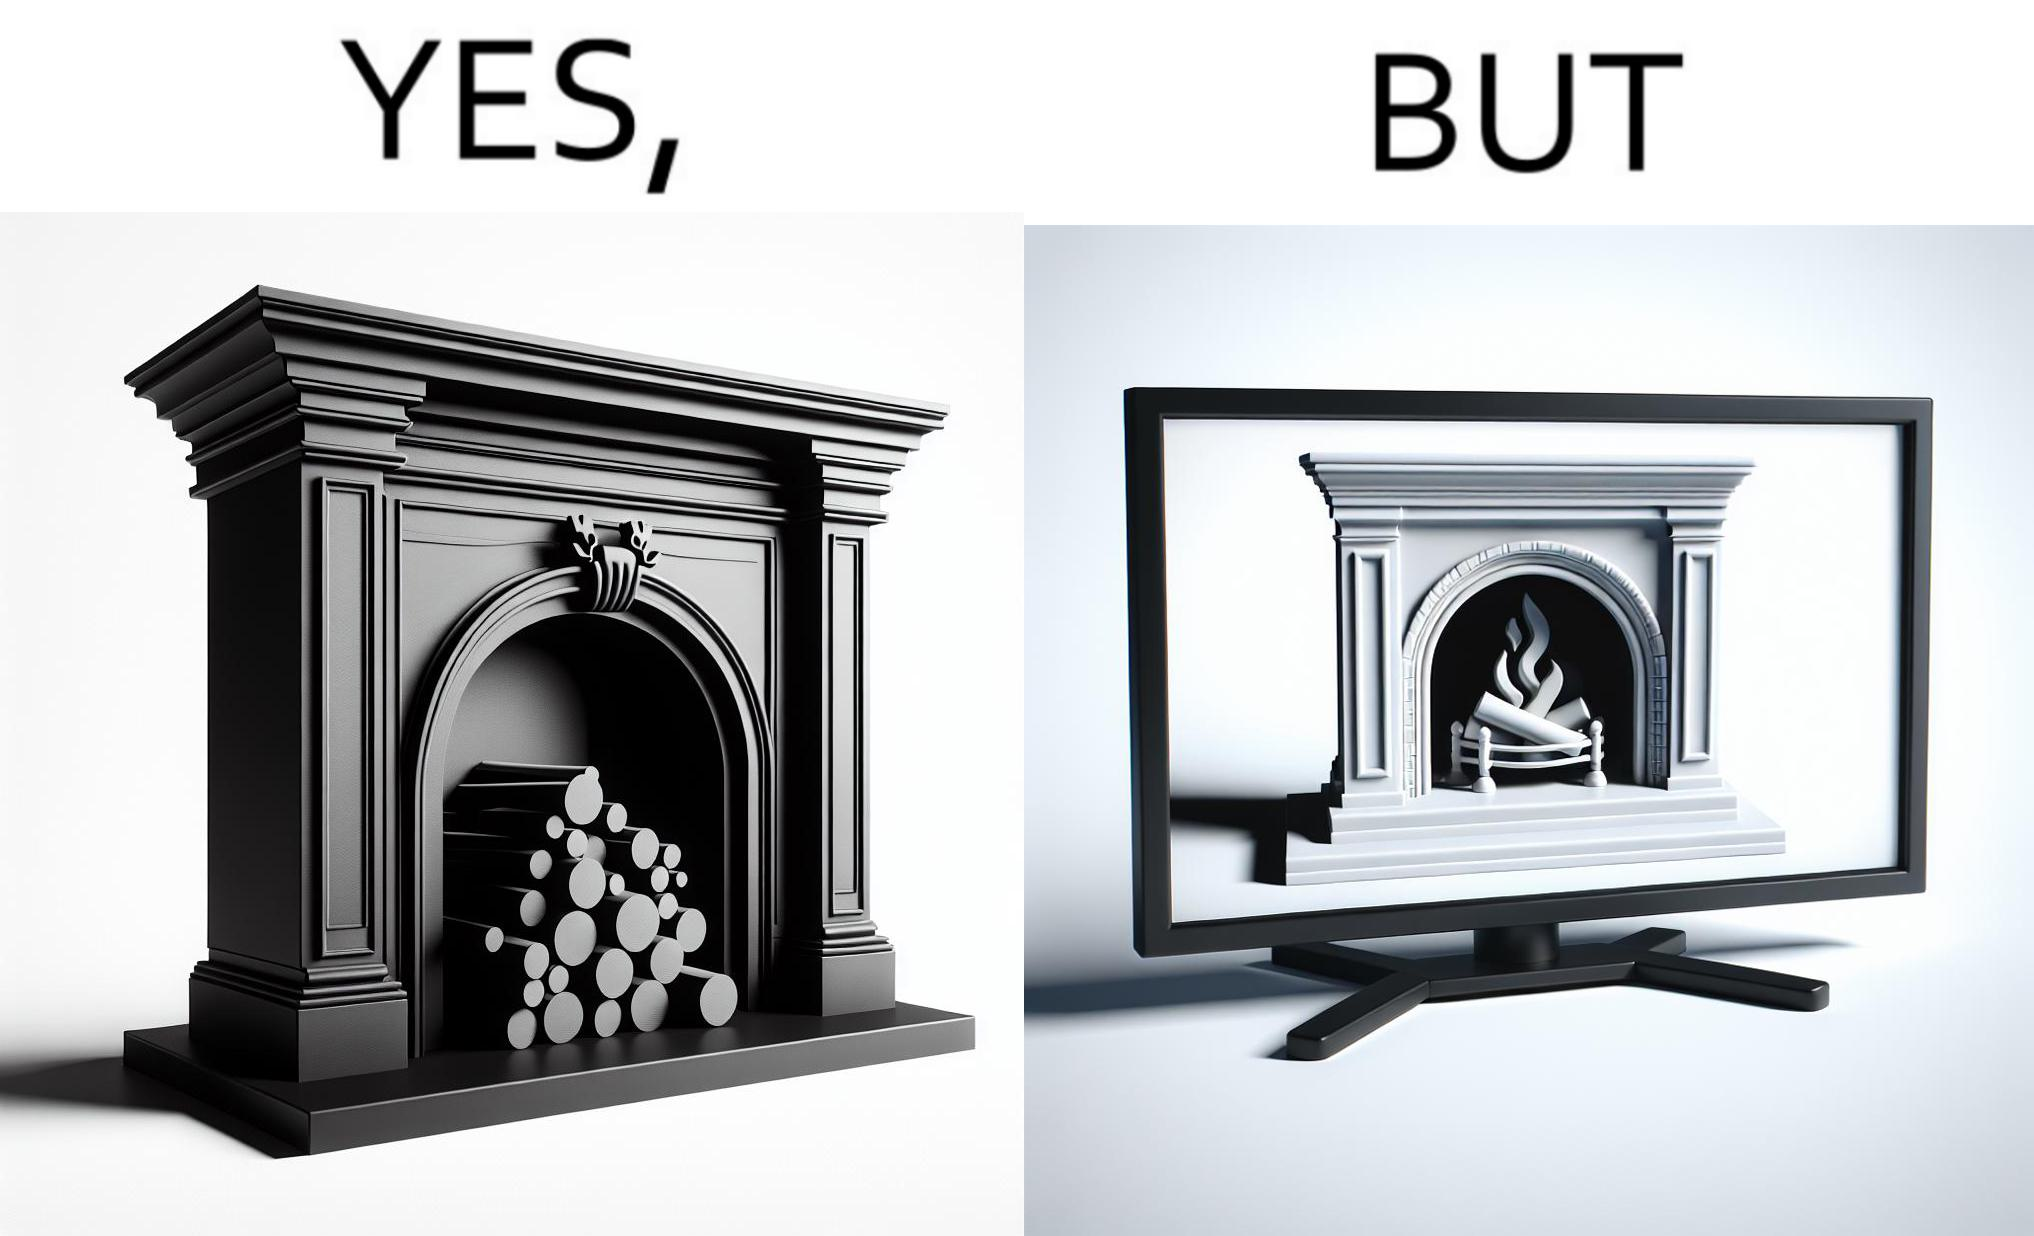Compare the left and right sides of this image. In the left part of the image: It is a fireplace In the right part of the image: It a fireplace being displayed on a television screen 